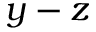Convert formula to latex. <formula><loc_0><loc_0><loc_500><loc_500>y - z</formula> 